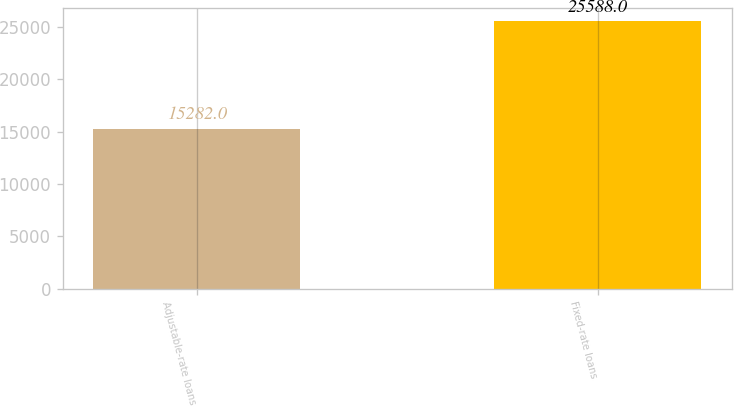<chart> <loc_0><loc_0><loc_500><loc_500><bar_chart><fcel>Adjustable-rate loans<fcel>Fixed-rate loans<nl><fcel>15282<fcel>25588<nl></chart> 